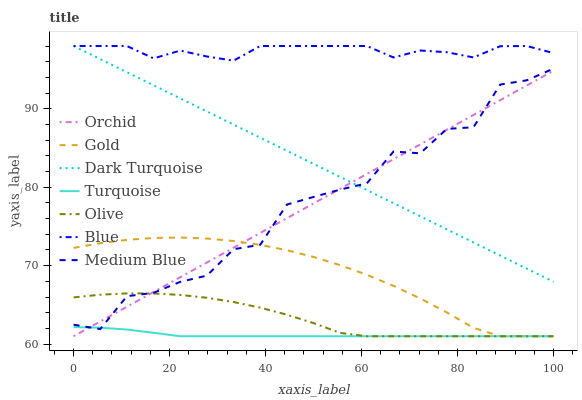Does Turquoise have the minimum area under the curve?
Answer yes or no. Yes. Does Blue have the maximum area under the curve?
Answer yes or no. Yes. Does Gold have the minimum area under the curve?
Answer yes or no. No. Does Gold have the maximum area under the curve?
Answer yes or no. No. Is Orchid the smoothest?
Answer yes or no. Yes. Is Medium Blue the roughest?
Answer yes or no. Yes. Is Turquoise the smoothest?
Answer yes or no. No. Is Turquoise the roughest?
Answer yes or no. No. Does Turquoise have the lowest value?
Answer yes or no. Yes. Does Dark Turquoise have the lowest value?
Answer yes or no. No. Does Dark Turquoise have the highest value?
Answer yes or no. Yes. Does Gold have the highest value?
Answer yes or no. No. Is Olive less than Dark Turquoise?
Answer yes or no. Yes. Is Dark Turquoise greater than Turquoise?
Answer yes or no. Yes. Does Gold intersect Orchid?
Answer yes or no. Yes. Is Gold less than Orchid?
Answer yes or no. No. Is Gold greater than Orchid?
Answer yes or no. No. Does Olive intersect Dark Turquoise?
Answer yes or no. No. 